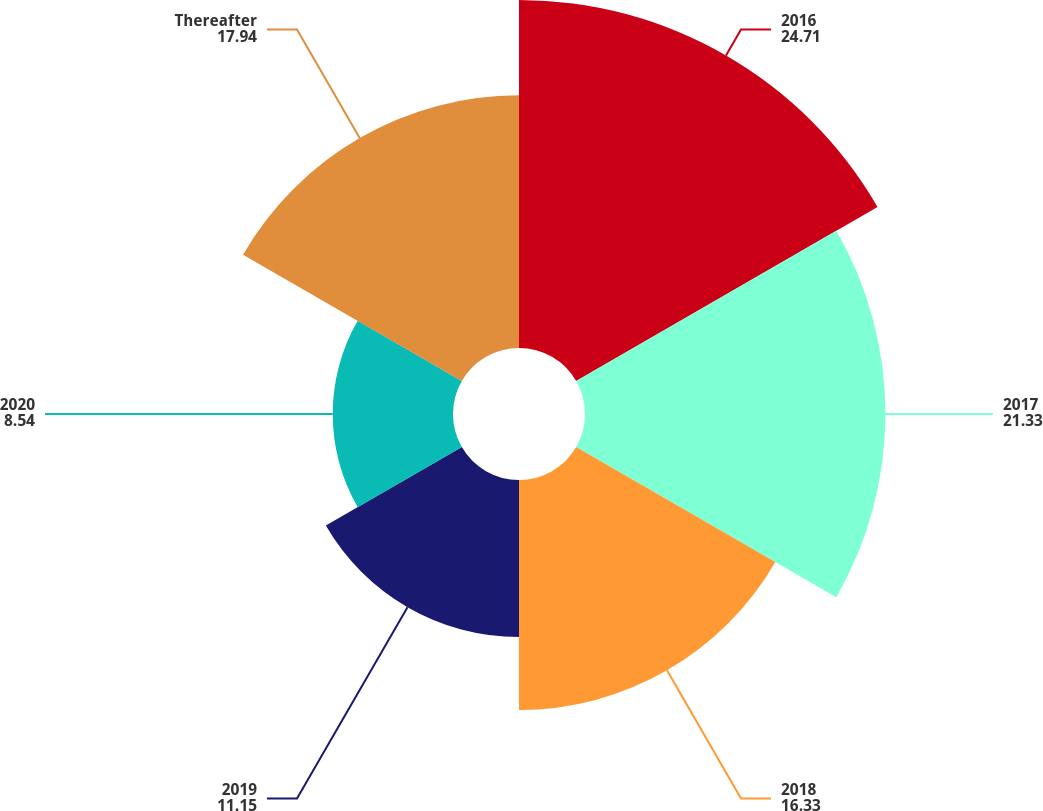Convert chart. <chart><loc_0><loc_0><loc_500><loc_500><pie_chart><fcel>2016<fcel>2017<fcel>2018<fcel>2019<fcel>2020<fcel>Thereafter<nl><fcel>24.71%<fcel>21.33%<fcel>16.33%<fcel>11.15%<fcel>8.54%<fcel>17.94%<nl></chart> 